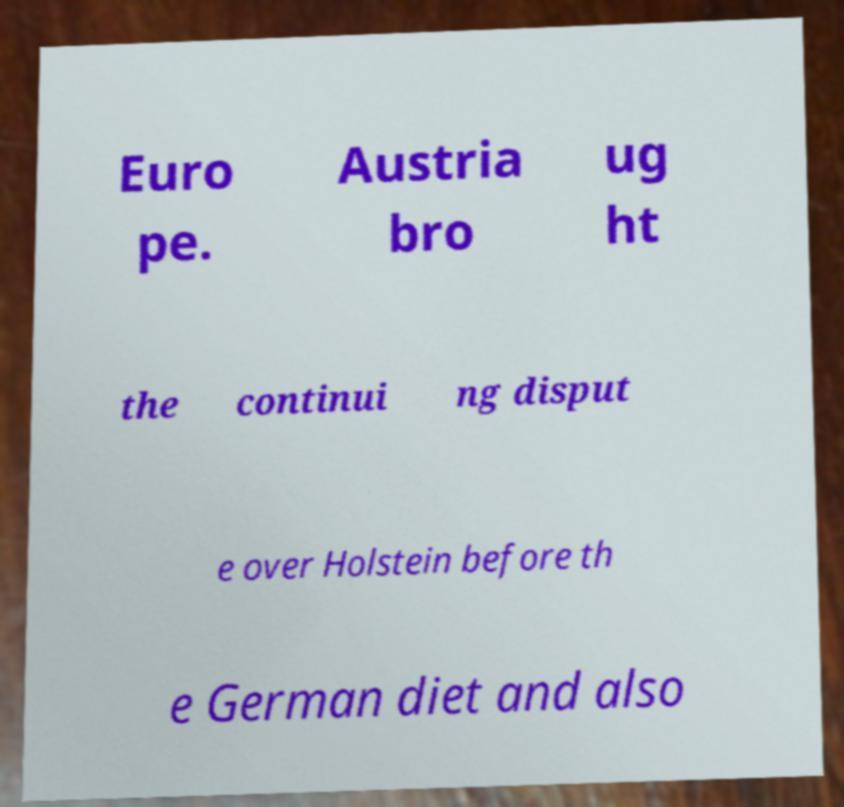There's text embedded in this image that I need extracted. Can you transcribe it verbatim? Euro pe. Austria bro ug ht the continui ng disput e over Holstein before th e German diet and also 